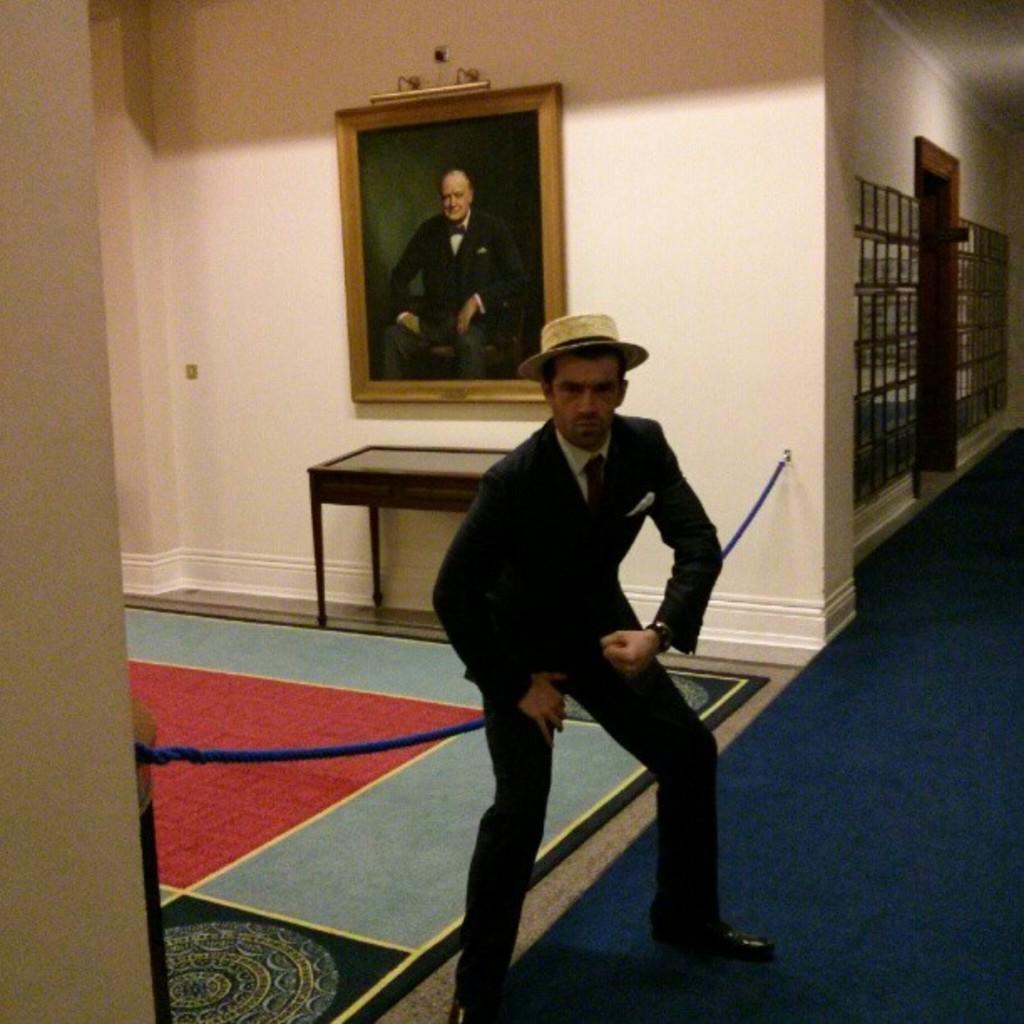How would you summarize this image in a sentence or two? Here in the center we can see a person wearing a hat and behind him we can see a table and a portrait present on the wall 